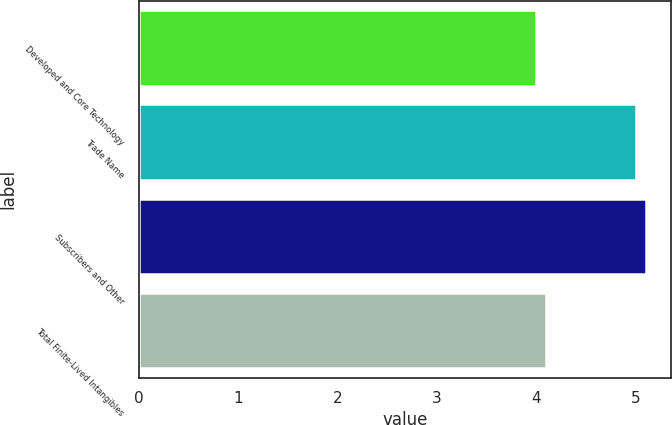Convert chart. <chart><loc_0><loc_0><loc_500><loc_500><bar_chart><fcel>Developed and Core Technology<fcel>Trade Name<fcel>Subscribers and Other<fcel>Total Finite-Lived Intangibles<nl><fcel>4<fcel>5<fcel>5.1<fcel>4.1<nl></chart> 